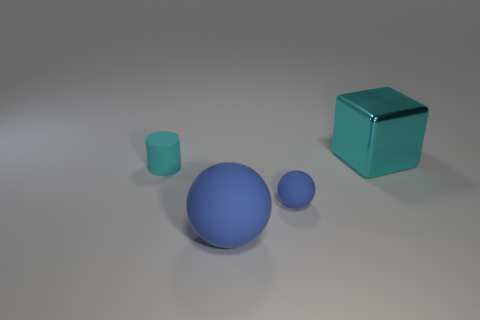Add 4 large red rubber cylinders. How many objects exist? 8 Subtract all cylinders. How many objects are left? 3 Subtract 0 purple spheres. How many objects are left? 4 Subtract all tiny cyan matte objects. Subtract all small rubber cylinders. How many objects are left? 2 Add 1 cyan rubber objects. How many cyan rubber objects are left? 2 Add 4 large rubber things. How many large rubber things exist? 5 